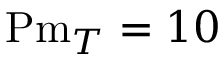<formula> <loc_0><loc_0><loc_500><loc_500>P m _ { T } = 1 0</formula> 